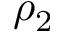Convert formula to latex. <formula><loc_0><loc_0><loc_500><loc_500>\rho _ { 2 }</formula> 